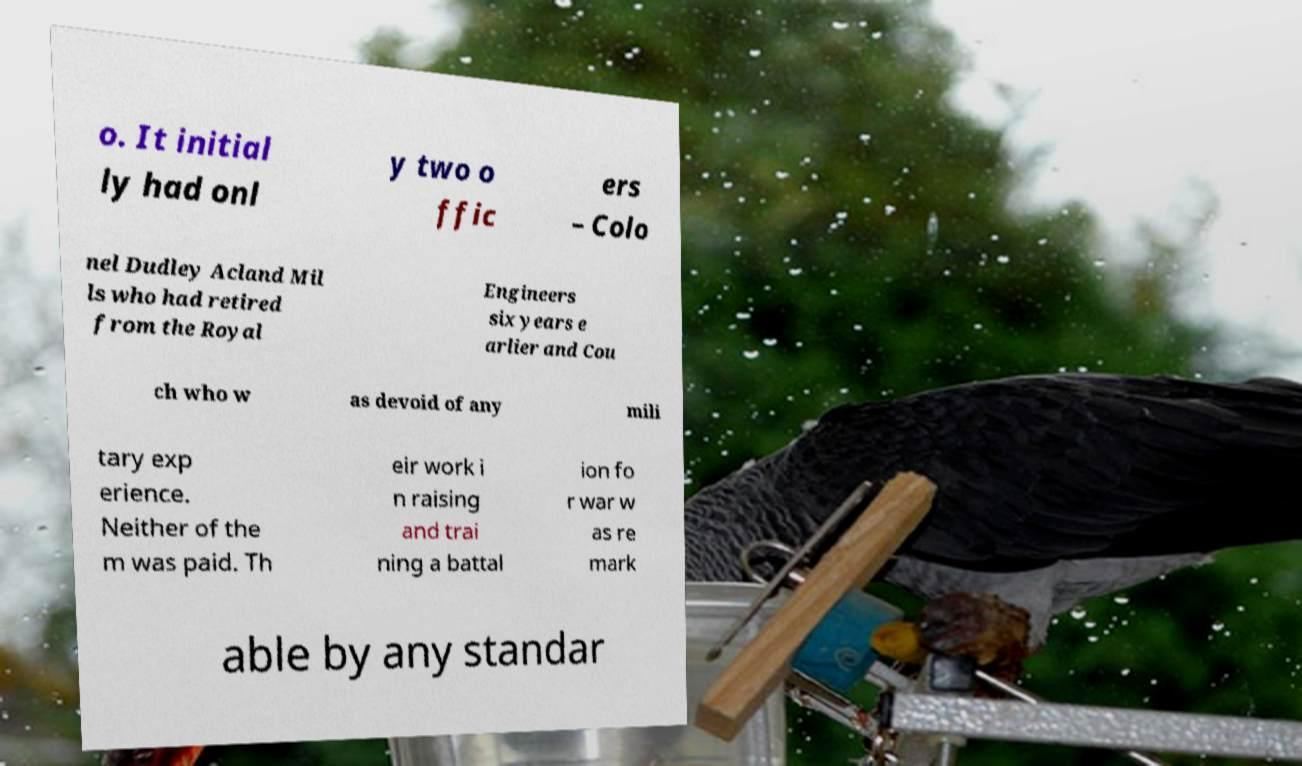Can you accurately transcribe the text from the provided image for me? o. It initial ly had onl y two o ffic ers – Colo nel Dudley Acland Mil ls who had retired from the Royal Engineers six years e arlier and Cou ch who w as devoid of any mili tary exp erience. Neither of the m was paid. Th eir work i n raising and trai ning a battal ion fo r war w as re mark able by any standar 